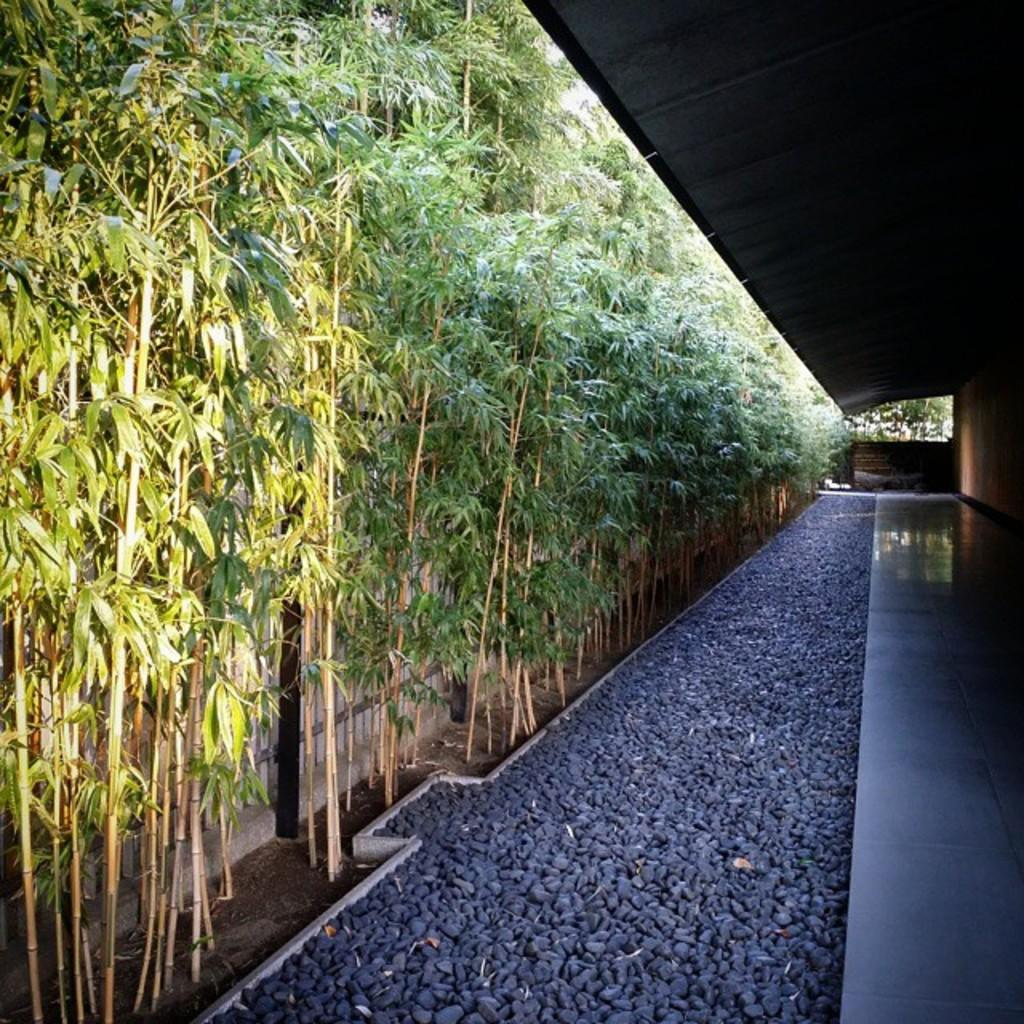What type of trees are present in the image? There are bamboo trees in the image. What can be seen at the bottom of the image? There are stones at the bottom of the image. Can you tell me how the woman expertly navigates the bamboo forest in the image? There is no woman or bamboo forest present in the image; it only features bamboo trees and stones. 